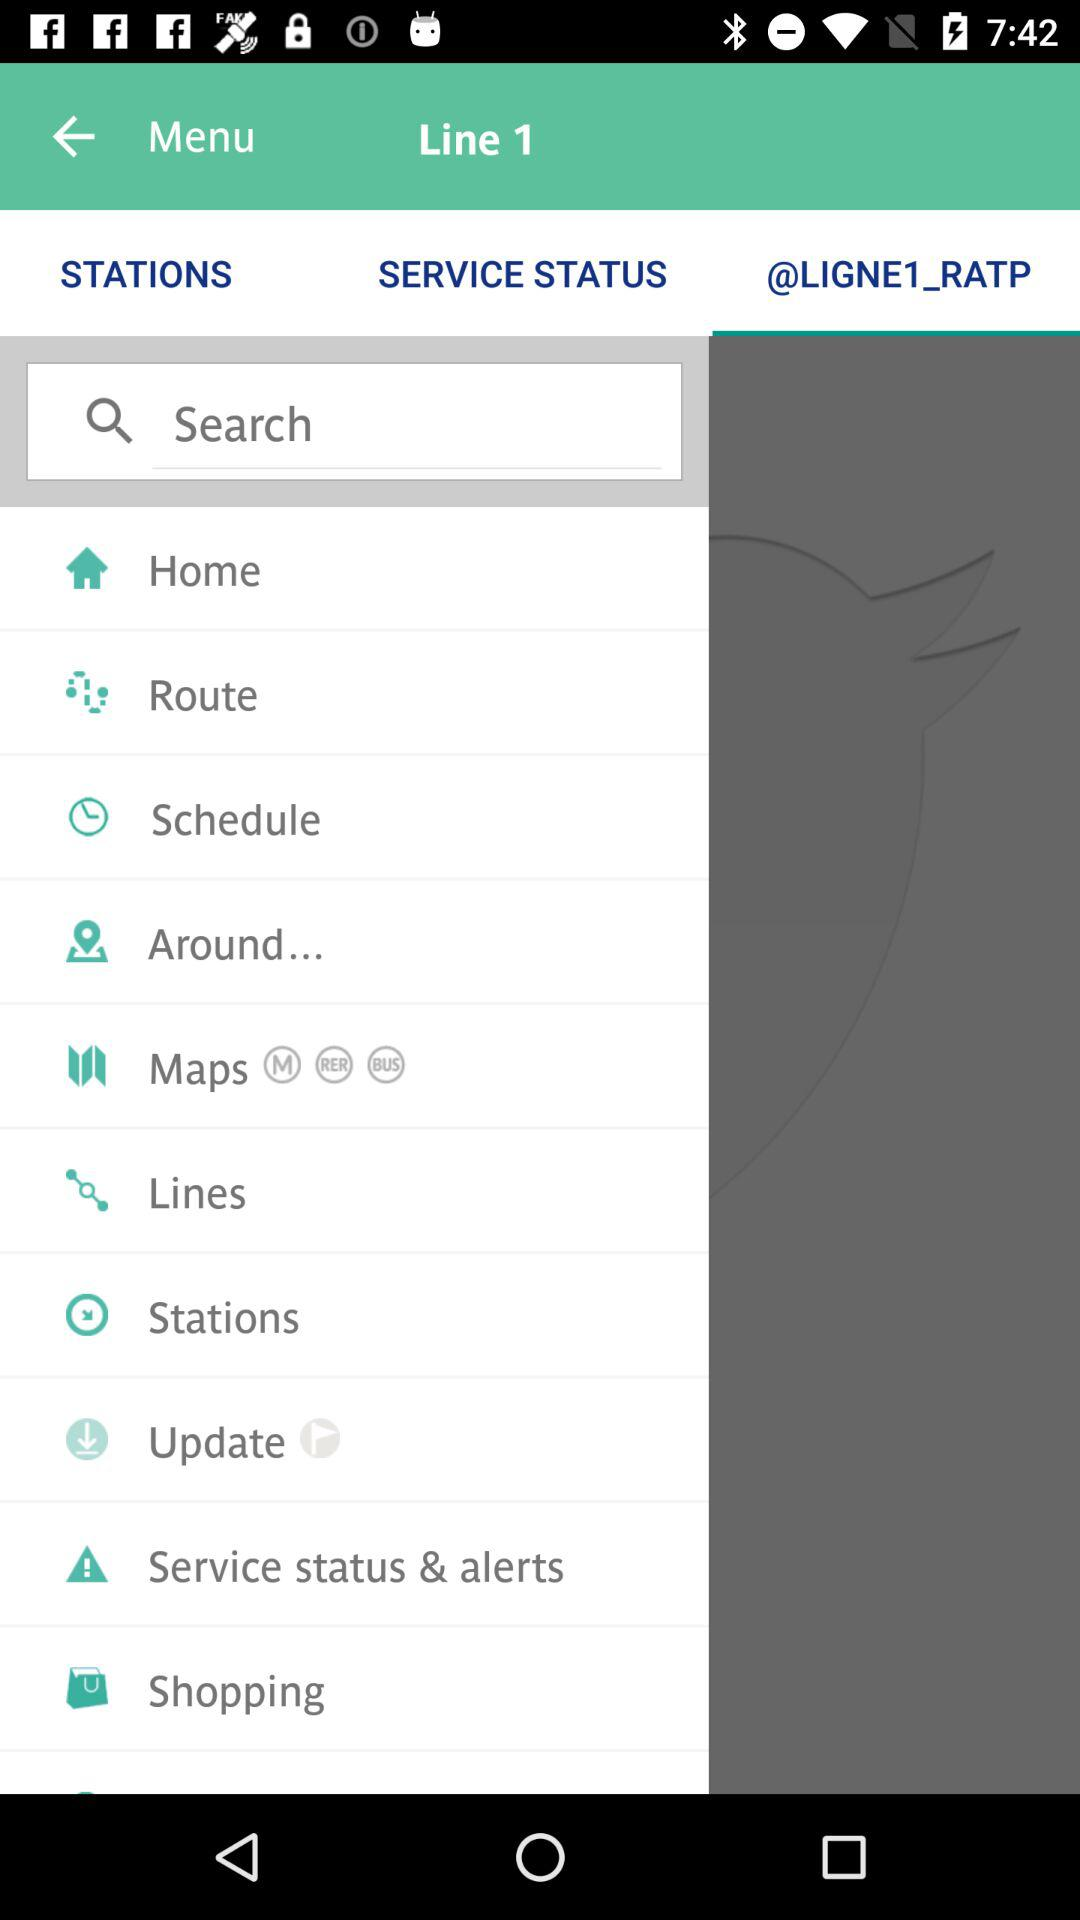Which tab am I on? You are on "@LIGNE1_RATP" tab. 